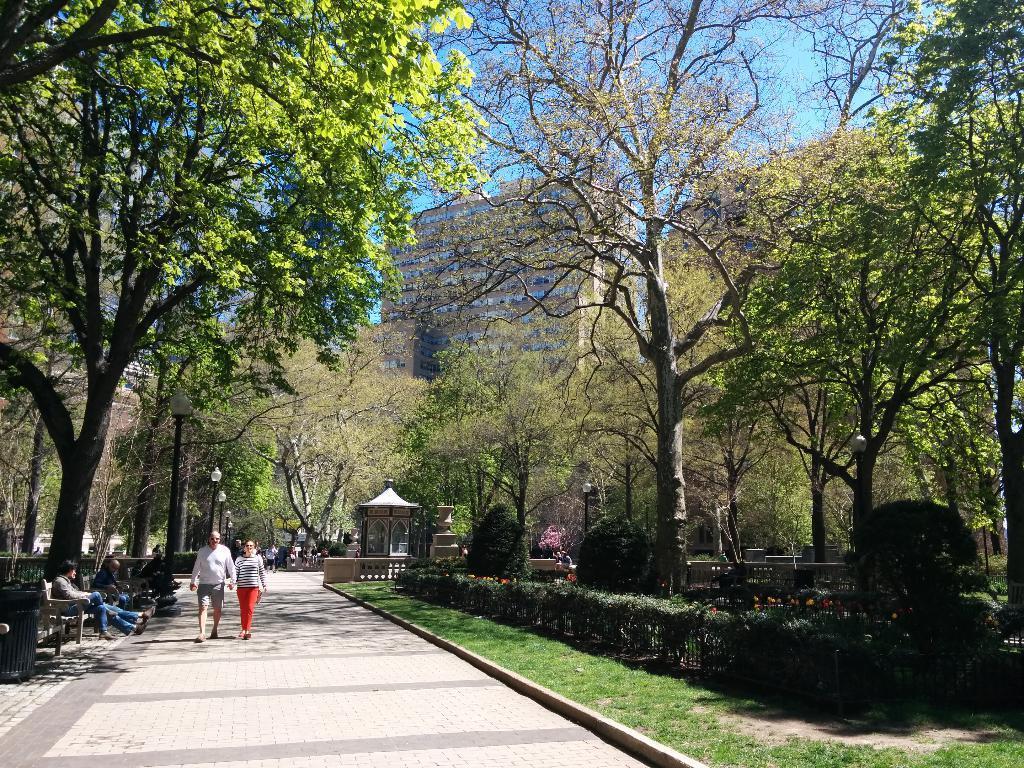Please provide a concise description of this image. In the foreground of this image, there are people walking on the path and we are sitting on the benches. We can also see the trees and poles. On the right, there are trees, shrubs and the grass. In the background, there are trees, buildings and the sky. 